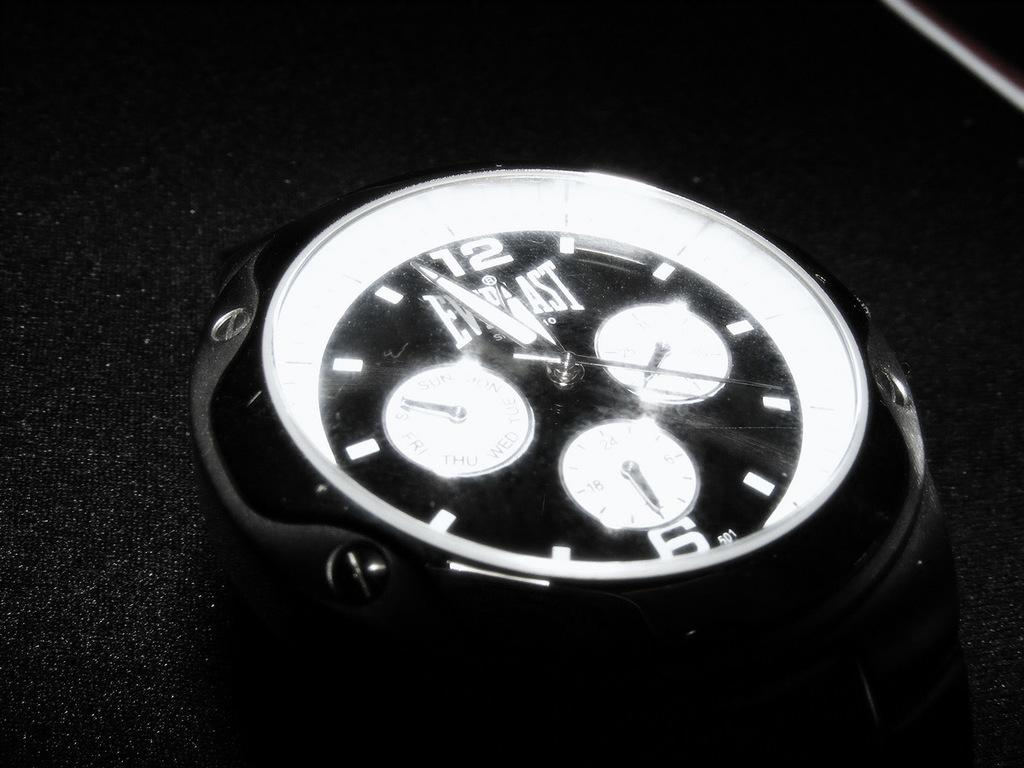<image>
Describe the image concisely. An Everlast stopwatch has three small dials in the center of the display area. 